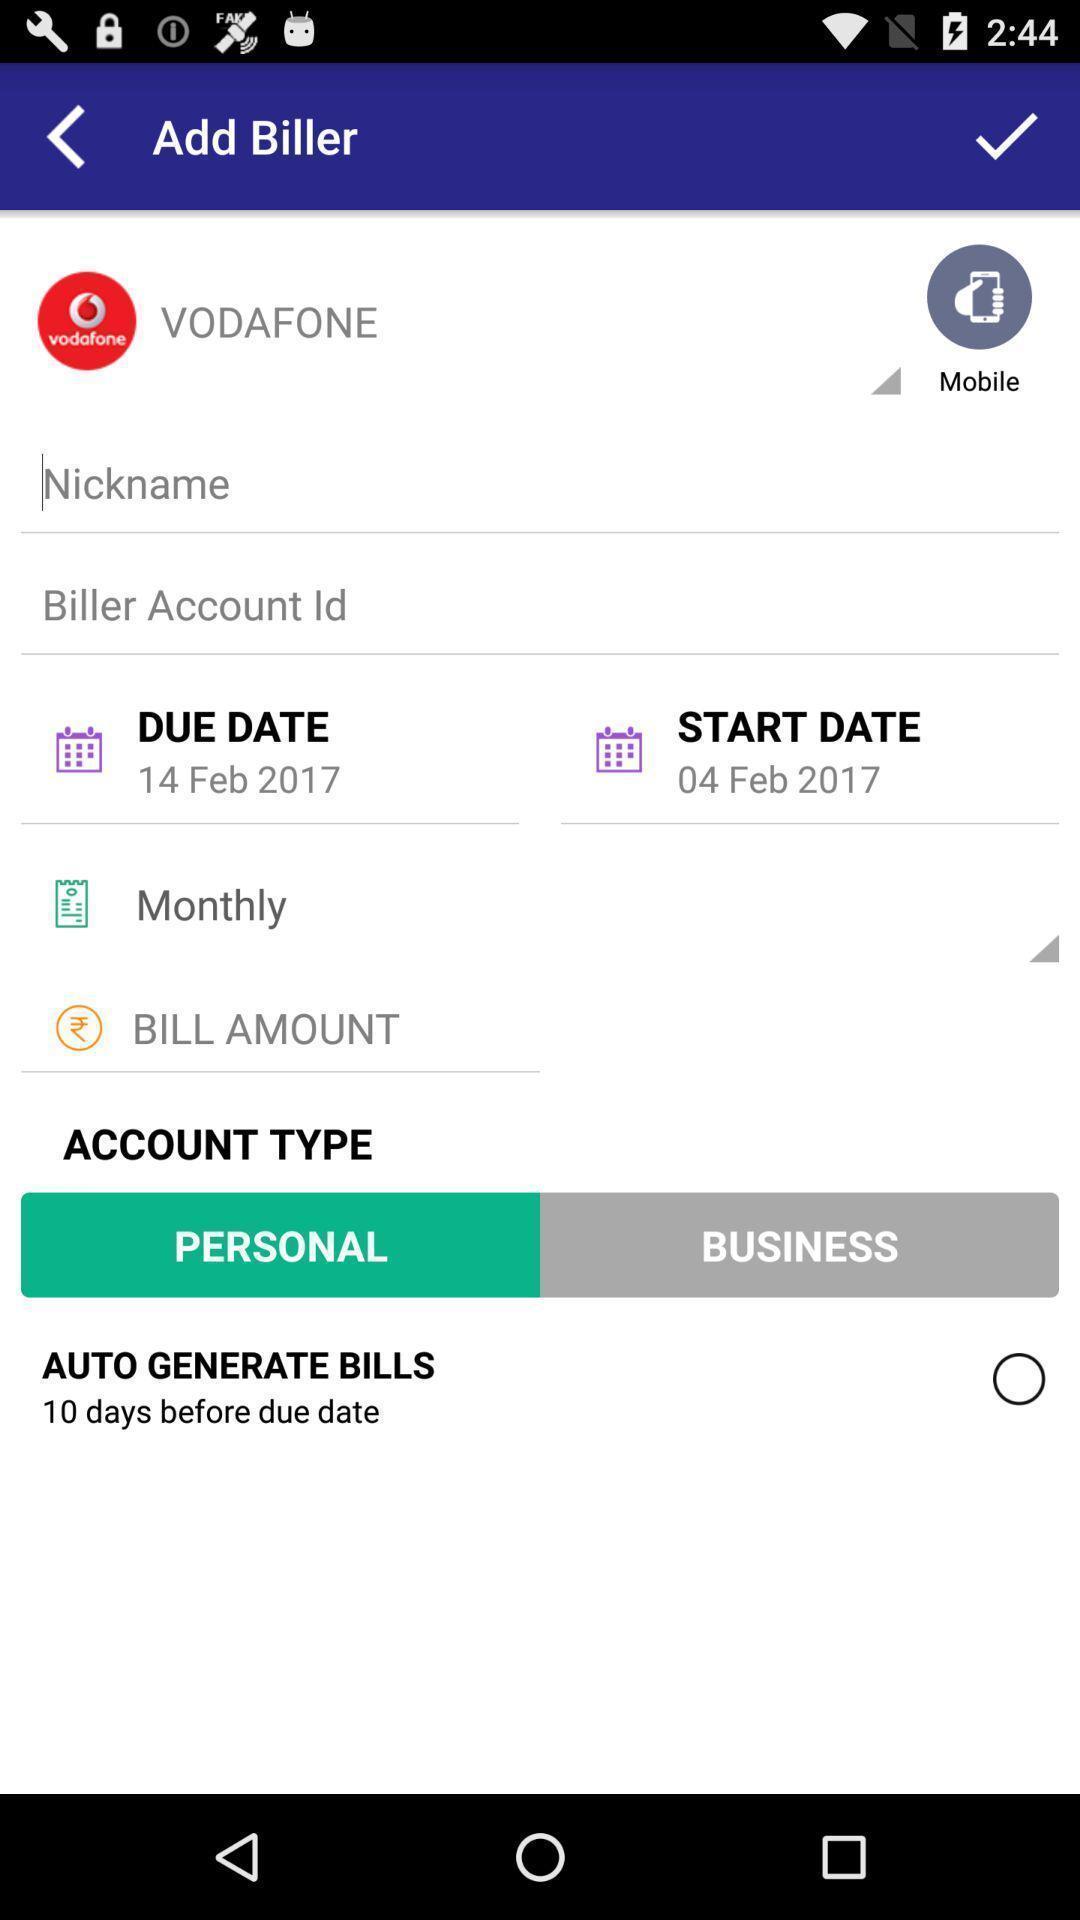Describe the visual elements of this screenshot. Screen shows billing details of a mobile network application. 